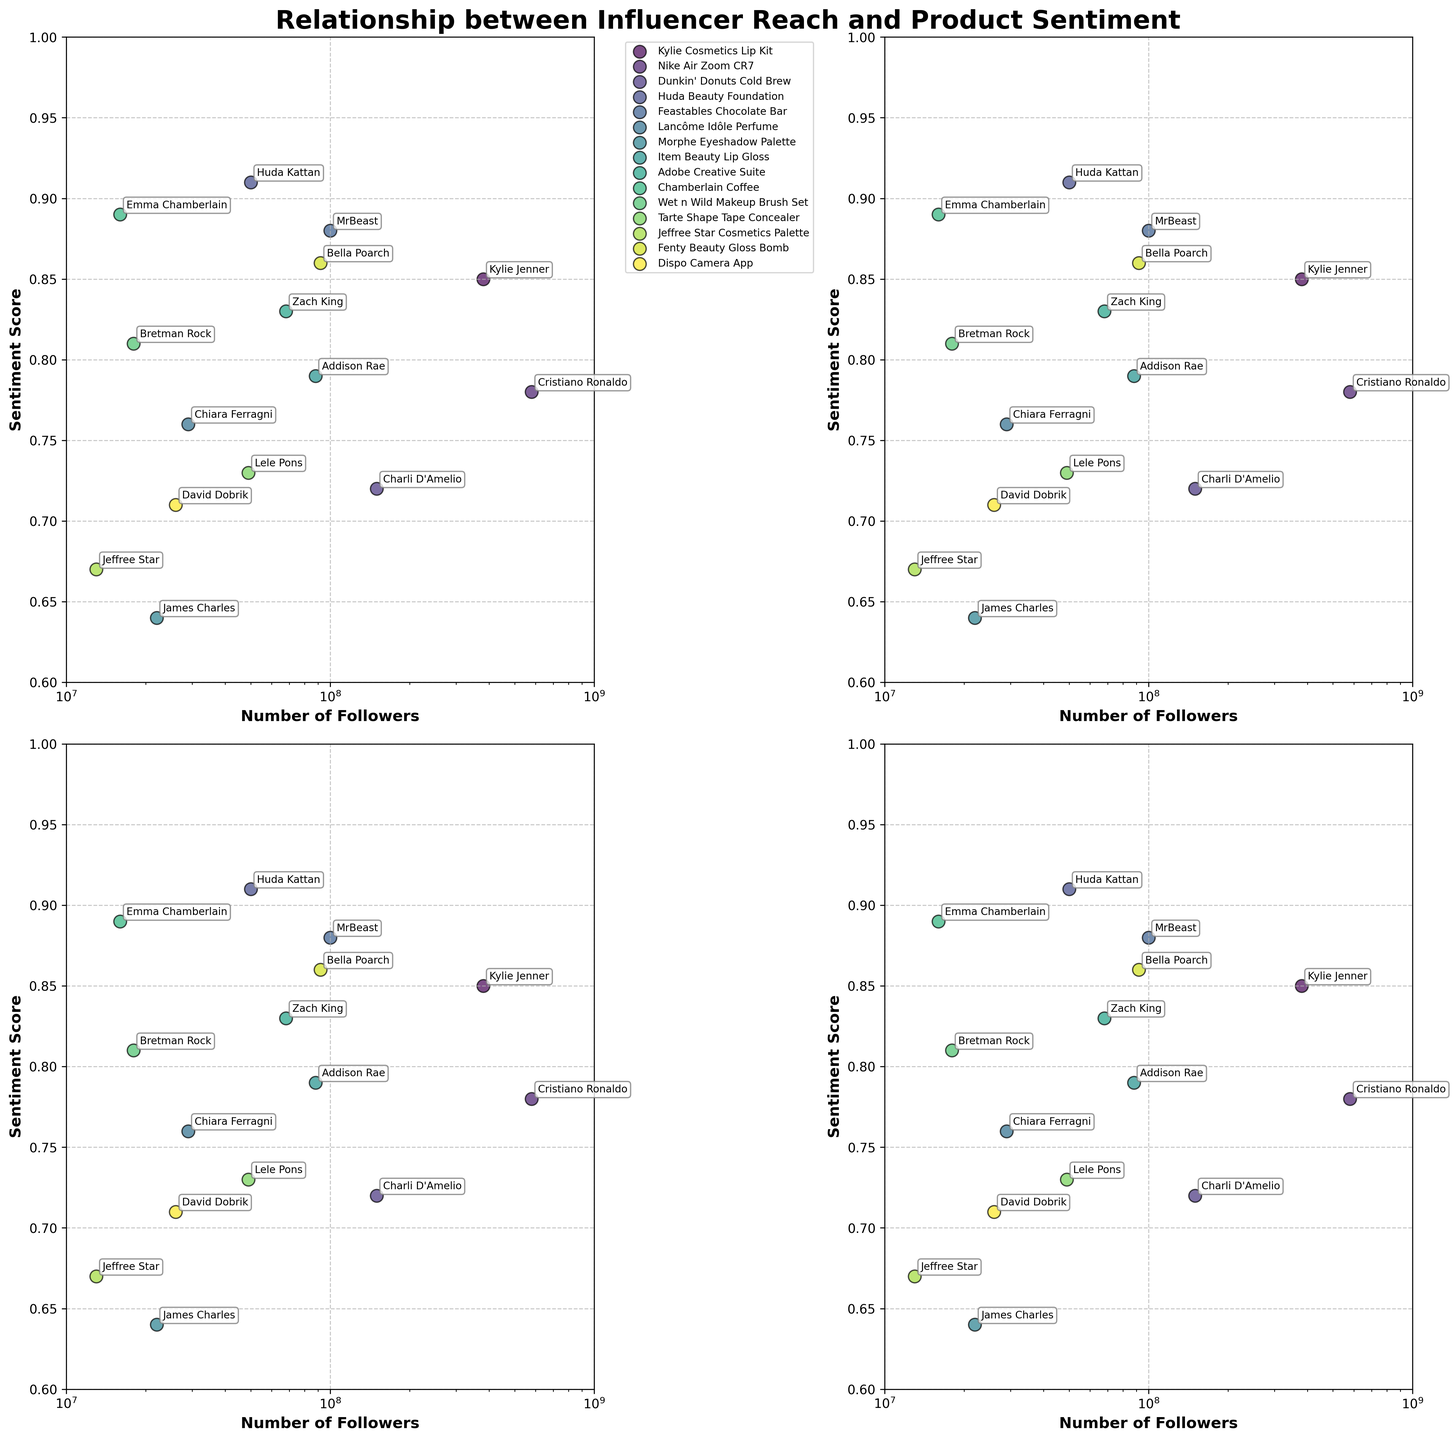What is the title of the figure? The title is usually displayed at the top of the figure. Here, it reads "Relationship between Influencer Reach and Product Sentiment."
Answer: Relationship between Influencer Reach and Product Sentiment Which influencer has the highest number of followers? From the scatter plot, the influencer with the highest follower count will be positioned farthest to the right on the x-axis. Cristiano Ronaldo, located near 580,000,000 followers, has the highest number.
Answer: Cristiano Ronaldo Which product has the highest sentiment score? To find the highest sentiment score, look for the point with the highest y-axis value. Huda Beauty Foundation, with Huda Kattan as the influencer, has a sentiment score of 0.91.
Answer: Huda Beauty Foundation How many influencers have a sentiment score above 0.8? Count the number of points above the 0.8 mark on the y-axis. The influencers are Kylie Jenner, MrBeast, Bella Poarch, Emma Chamberlain, and Zach King.
Answer: 5 What is the approximate sentiment score for 'Dunkin' Donuts Cold Brew'? Find the scatter point labeled 'Charli D'Amelio' associated with 'Dunkin' Donuts Cold Brew.' The y-axis value near the point is approximately 0.72.
Answer: 0.72 Which product has the most similar sentiment score to 'Adobe Creative Suite'? Compare the sentiment scores on the y-axis and find the closest one to 'Adobe Creative Suite' (0.83), which is 'Chamberlain Coffee' at 0.89.
Answer: Chamberlain Coffee Is there a product with a sentiment score below 0.7? If yes, name it. Look for points below the 0.7 horizontal line on the y-axis. The product 'Dispo Camera App' has a sentiment score of 0.71, but 'Jeffree Star Cosmetics Palette' has the lowest score at 0.67.
Answer: Jeffree Star Cosmetics Palette Who is the influencer with a sentiment score closest to 0.85? Identify the influencer close to the 0.85 value on the y-axis. Kylie Jenner with 'Kylie Cosmetics Lip Kit' fits this sentiment score.
Answer: Kylie Jenner What is the overall trend of sentiment score in relation to the number of followers? Observe the distribution of points across the plot. While there's no clear linear trend, it appears that products with a higher number of followers do not necessarily have a higher sentiment score.
Answer: No clear trend Who are the influencers with product sentiment scores between 0.75 and 0.80? Check the scatter points within the y-axis range of 0.75 to 0.80. The influencers in this range are Cristiano Ronaldo, Chiara Ferragni, Lele Pons, and Addison Rae.
Answer: Cristiano Ronaldo, Chiara Ferragni, Lele Pons, Addison Rae 